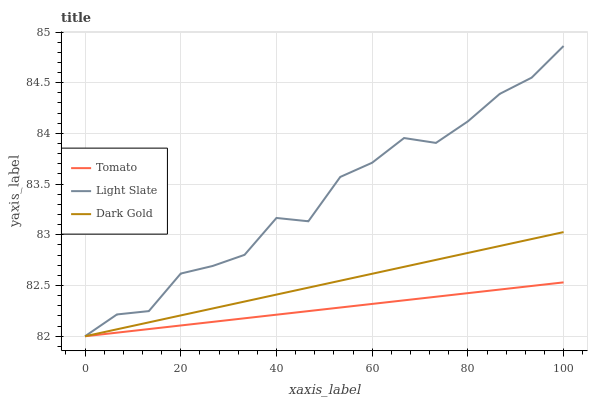Does Tomato have the minimum area under the curve?
Answer yes or no. Yes. Does Light Slate have the maximum area under the curve?
Answer yes or no. Yes. Does Dark Gold have the minimum area under the curve?
Answer yes or no. No. Does Dark Gold have the maximum area under the curve?
Answer yes or no. No. Is Dark Gold the smoothest?
Answer yes or no. Yes. Is Light Slate the roughest?
Answer yes or no. Yes. Is Light Slate the smoothest?
Answer yes or no. No. Is Dark Gold the roughest?
Answer yes or no. No. Does Tomato have the lowest value?
Answer yes or no. Yes. Does Light Slate have the highest value?
Answer yes or no. Yes. Does Dark Gold have the highest value?
Answer yes or no. No. Does Light Slate intersect Dark Gold?
Answer yes or no. Yes. Is Light Slate less than Dark Gold?
Answer yes or no. No. Is Light Slate greater than Dark Gold?
Answer yes or no. No. 